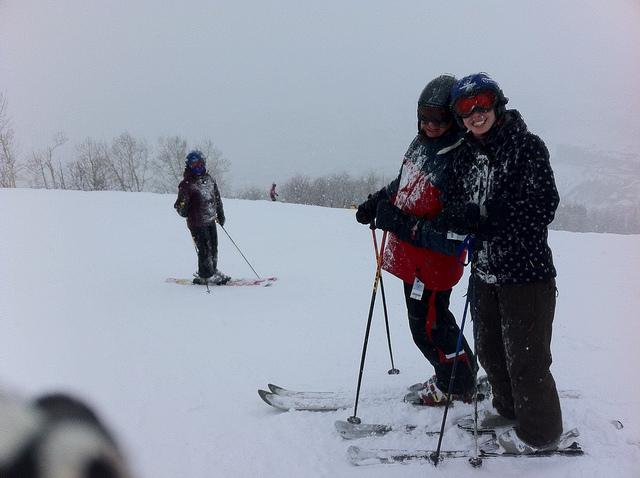To which elevation will the persons pictured here likely go to on their skis? Please explain your reasoning. lower. They are on the downhill section and there is no ski lift around. 